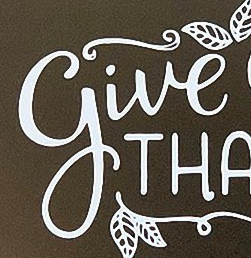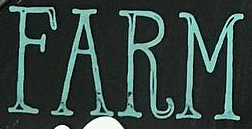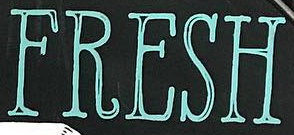What words are shown in these images in order, separated by a semicolon? give; FARM; FRESH 